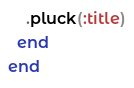Convert code to text. <code><loc_0><loc_0><loc_500><loc_500><_Ruby_>    .pluck(:title)
  end
end
</code> 